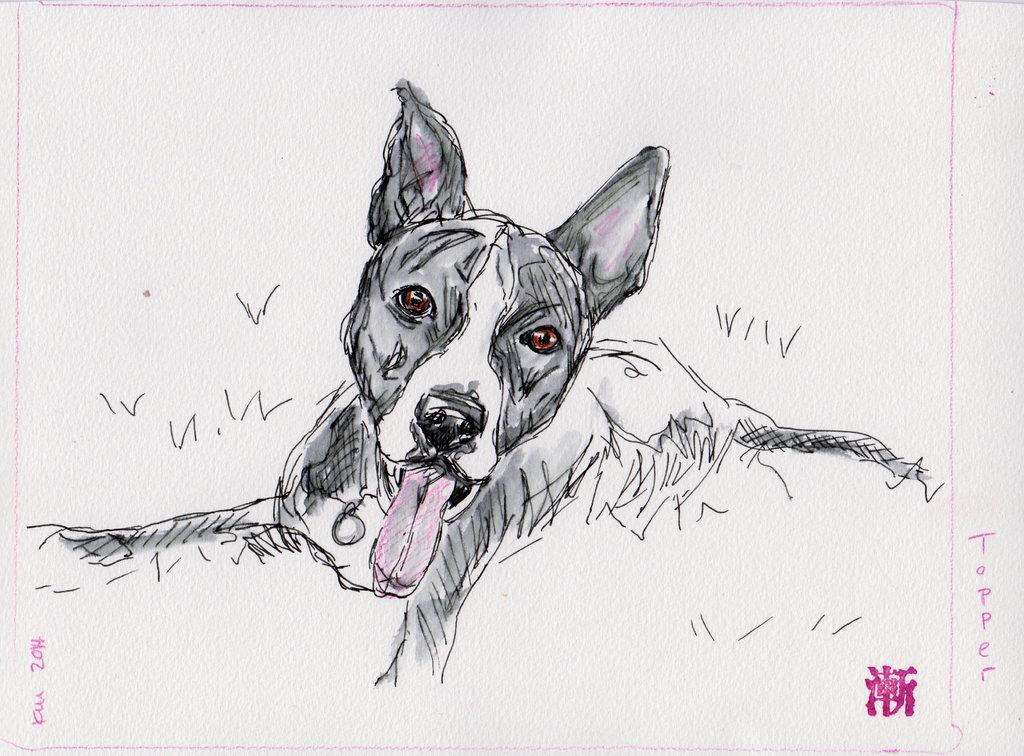What is depicted in the image? There is a sketch in the image. What is the subject of the sketch? The sketch is of a dog. What is the color of the sheet on which the sketch is drawn? The sketch is on a white color sheet. What type of metal is used to create the dog's collar in the sketch? There is no metal or collar present in the sketch; it is a simple drawing of a dog. 